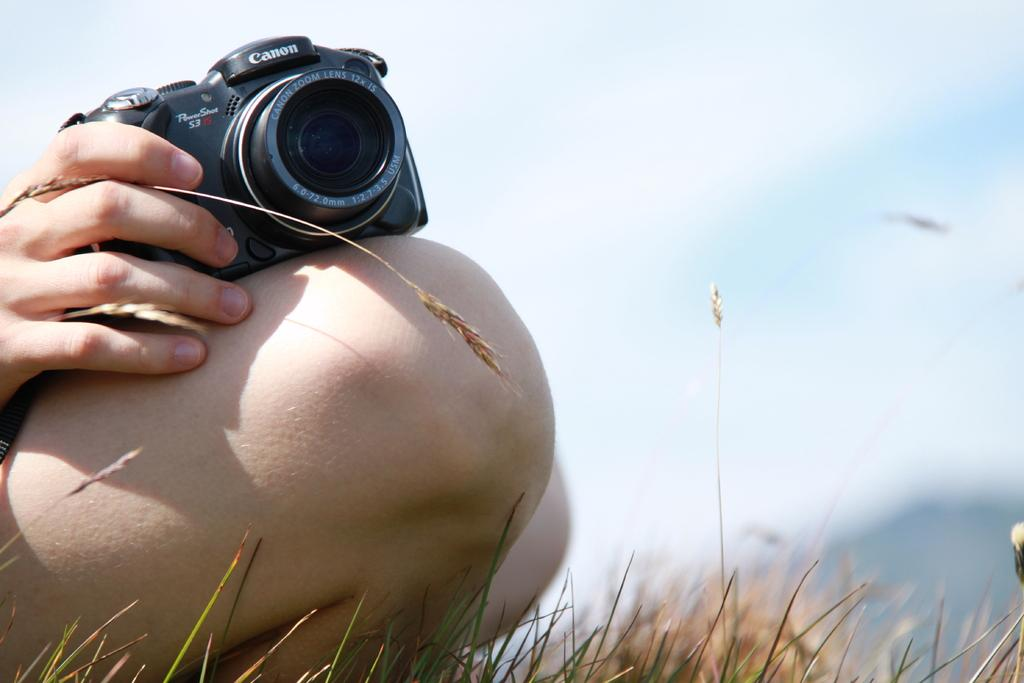What is the person holding in their hand in the image? The person is holding a camera in their hand. How is the camera positioned in relation to the person? The camera is placed on the person's leg. What type of surface is visible in front of the person's legs? There is grass visible in front of the person's legs. What type of watch is the achiever wearing in the image? There is no achiever or watch present in the image. Who is the friend standing next to the person in the image? There is no friend visible in the image; only the person holding the camera is present. 